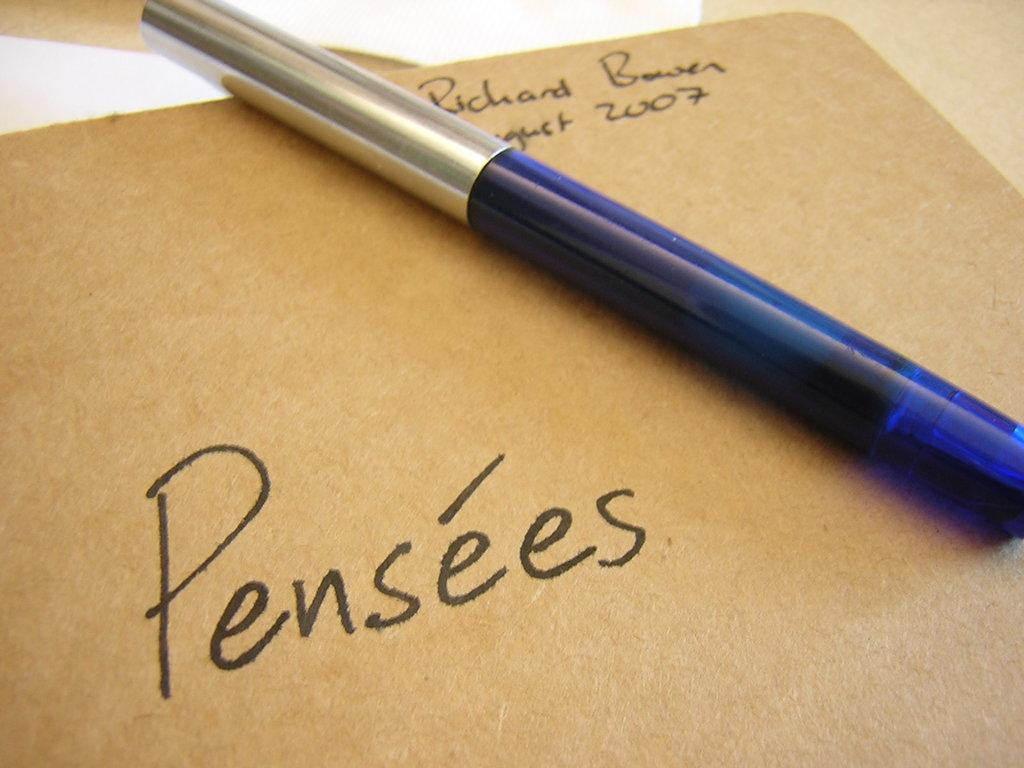What is the main object in the image? There is a writing pad in the image. What is written or drawn on the writing pad? There is text on the writing pad. What is used for writing on the writing pad? There is a pen on the writing pad. What is located at the top of the image? There is a paper at the top of the image. What type of animal can be seen interacting with the writing pad in the image? There is no animal present in the image, and therefore no such interaction can be observed. What type of lawyer is depicted in the image? There is no lawyer depicted in the image; it features a writing pad with text and a pen. 